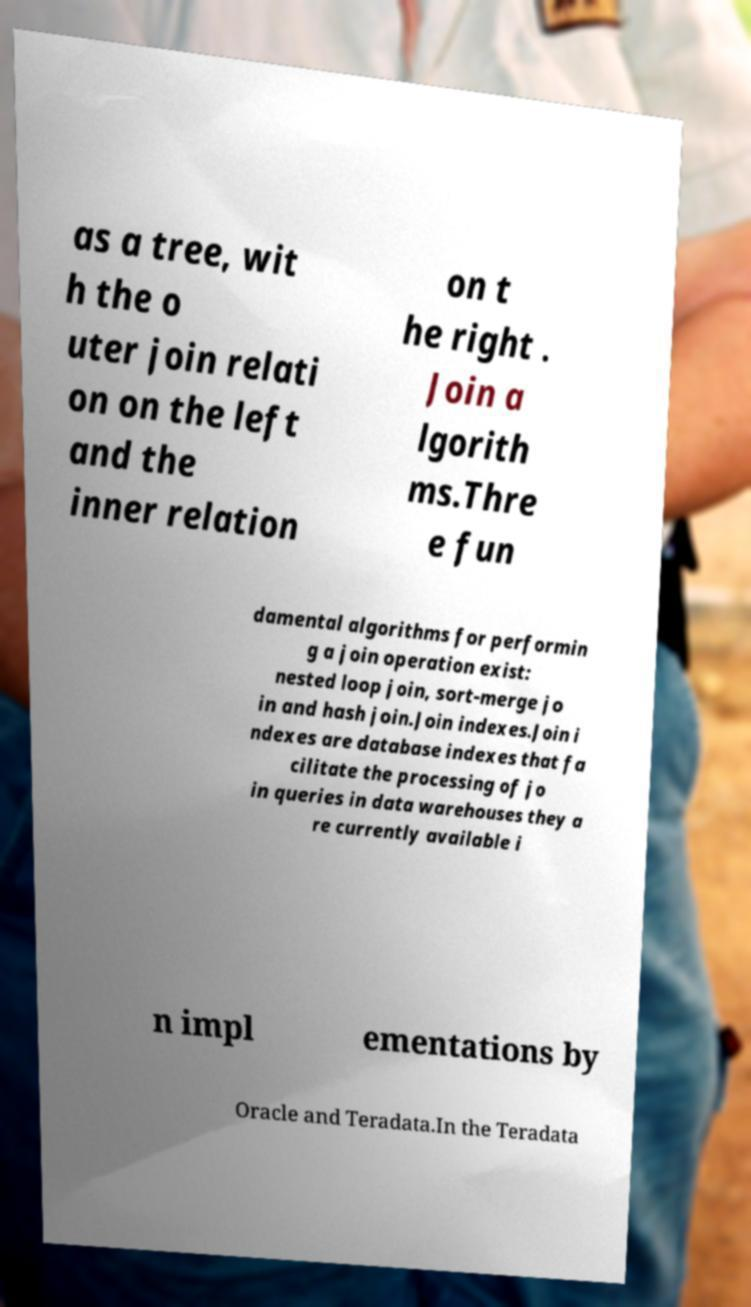For documentation purposes, I need the text within this image transcribed. Could you provide that? as a tree, wit h the o uter join relati on on the left and the inner relation on t he right . Join a lgorith ms.Thre e fun damental algorithms for performin g a join operation exist: nested loop join, sort-merge jo in and hash join.Join indexes.Join i ndexes are database indexes that fa cilitate the processing of jo in queries in data warehouses they a re currently available i n impl ementations by Oracle and Teradata.In the Teradata 